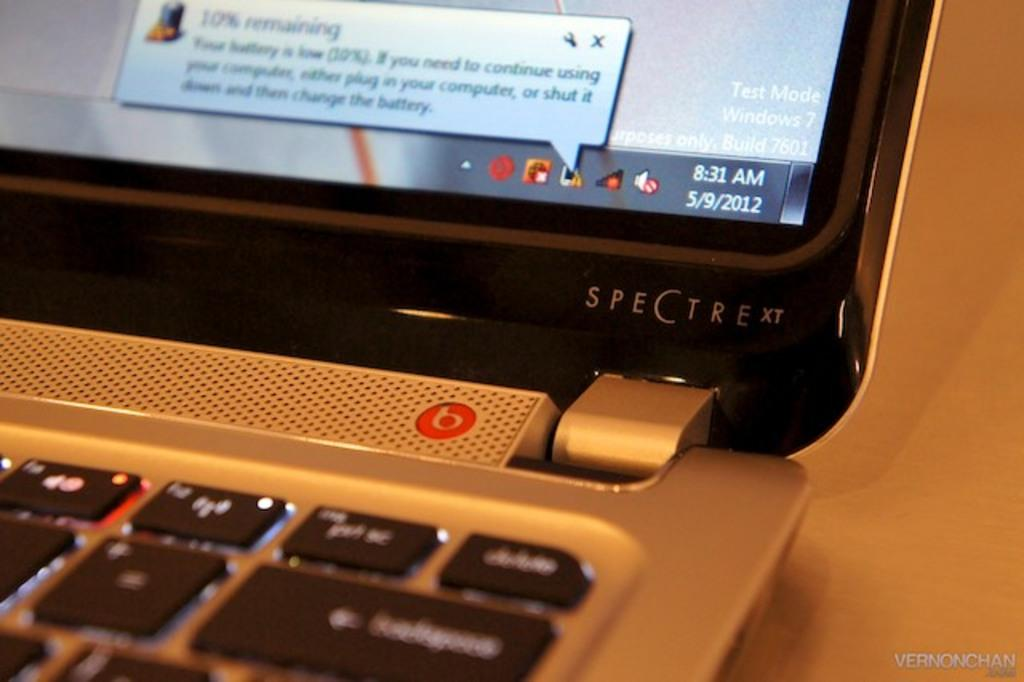<image>
Offer a succinct explanation of the picture presented. A laptop made by the company SPECTRE is open. 